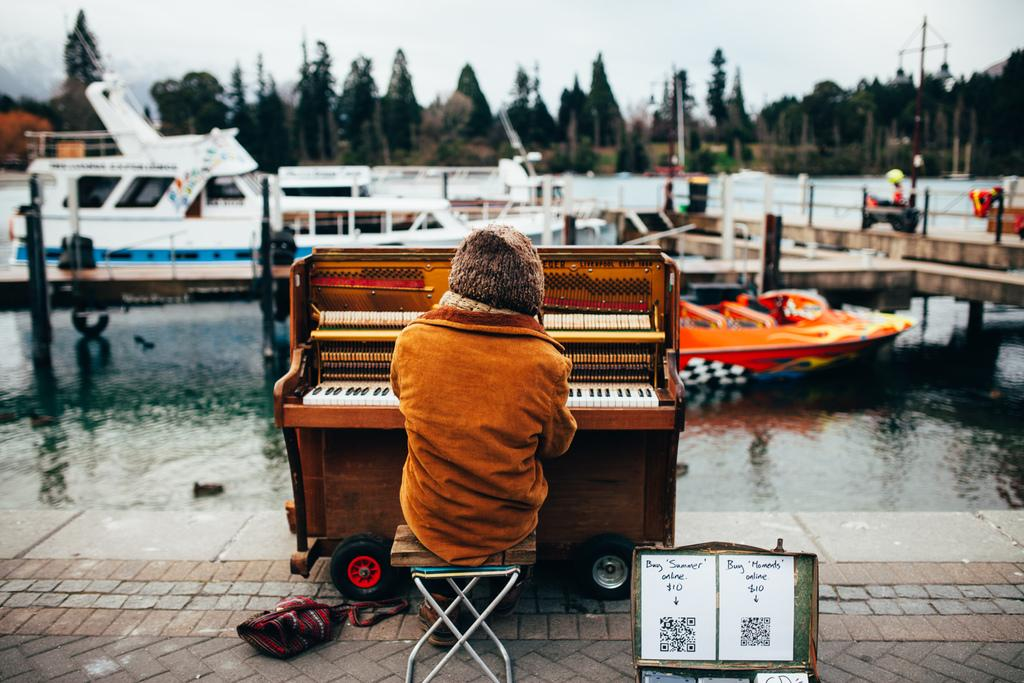What is the man in the image doing? The man is sitting on a stool in the image. What is located next to the man? The man is next to a musical instrument. What can be seen in the background of the image? There is water, boats, and trees visible in the background of the image. What type of snail can be seen crawling on the man's body in the image? There is no snail present in the image, and the man's body is not visible. What letters are written on the musical instrument in the image? The provided facts do not mention any letters on the musical instrument, so we cannot determine if any letters are present. 